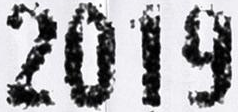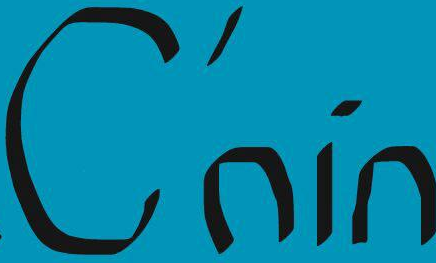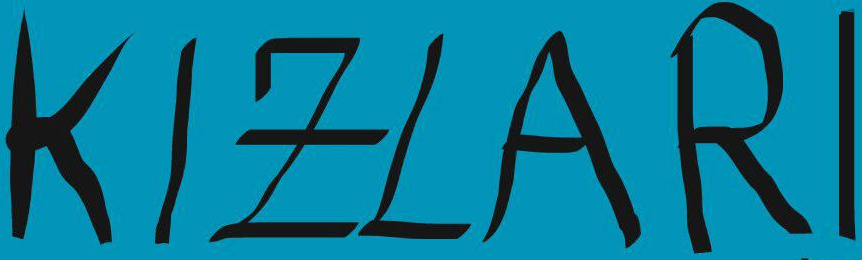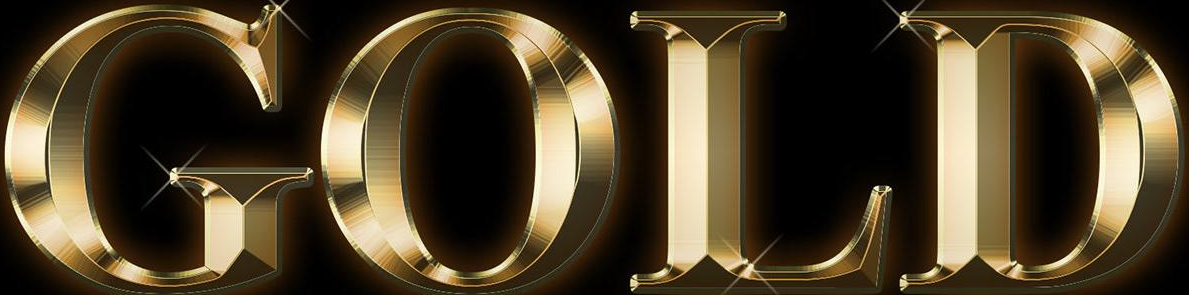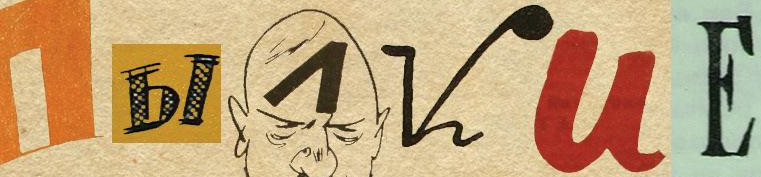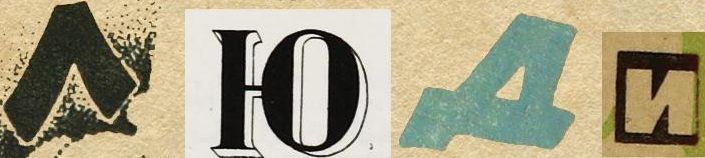Transcribe the words shown in these images in order, separated by a semicolon. 2019; C'nin; KIZLARI; GOLD; I##VUЕ; #### 